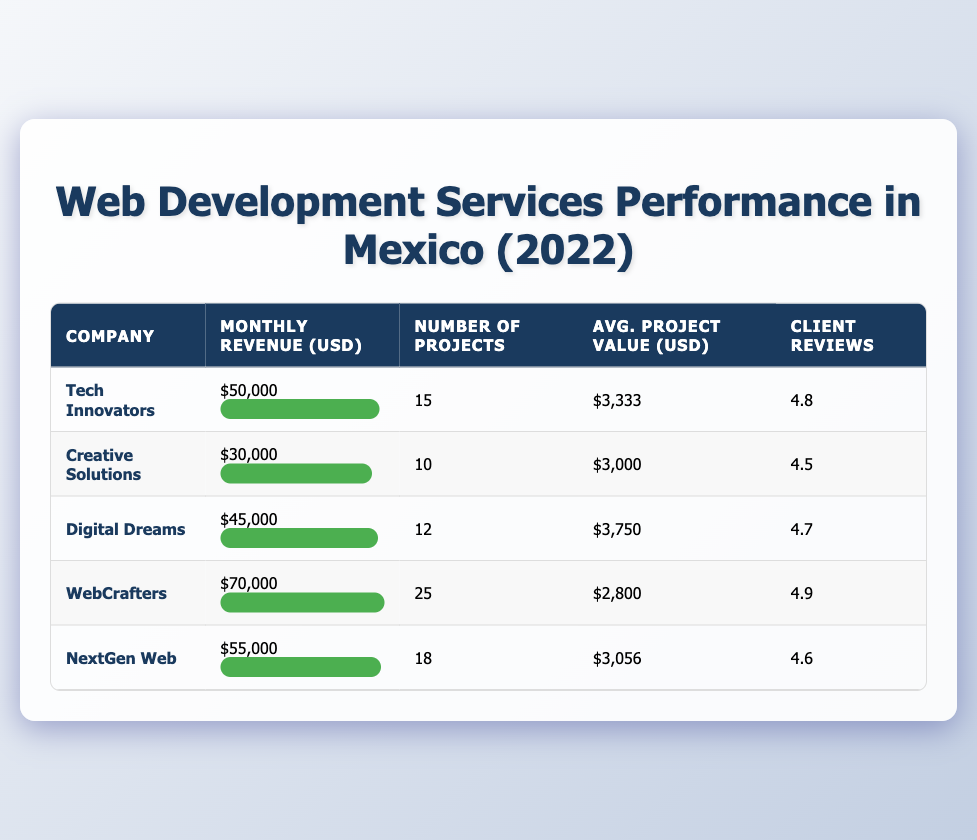What is the company with the highest monthly revenue? To find the company with the highest monthly revenue, I can compare the monthly revenue values from the table. The companies are WebCrafters ($70,000), NextGen Web ($55,000), Tech Innovators ($50,000), Digital Dreams ($45,000), and Creative Solutions ($30,000). WebCrafters has the highest revenue at $70,000.
Answer: WebCrafters What is the average project value for Creative Solutions? The average project value for Creative Solutions is displayed in the table as $3,000. There are no calculations needed as it is a specific value shown directly.
Answer: $3,000 How many projects did the company Digital Dreams complete? The number of projects completed by Digital Dreams is listed in the table as 12. This is a straightforward retrieval from the respective row of the table.
Answer: 12 What is the total monthly revenue of all listed companies? To find the total monthly revenue, I will sum the revenues of all companies: $50,000 (Tech Innovators) + $30,000 (Creative Solutions) + $45,000 (Digital Dreams) + $70,000 (WebCrafters) + $55,000 (NextGen Web) = $250,000.
Answer: $250,000 Is there any company with a client review rating of 5.0? By reviewing the client reviews in the table, I see the highest rating is 4.9 (WebCrafters), and no company has a rating of 5.0. Therefore, the answer is no.
Answer: No What is the difference in monthly revenue between WebCrafters and Creative Solutions? The monthly revenue for WebCrafters is $70,000 and for Creative Solutions it is $30,000. To find the difference, I will subtract: $70,000 - $30,000 = $40,000.
Answer: $40,000 How many more projects did WebCrafters complete compared to NextGen Web? WebCrafters completed 25 projects while NextGen Web completed 18 projects. I will calculate the difference: 25 - 18 = 7.
Answer: 7 What percentage of the average project value is associated with Digital Dreams compared to Tech Innovators? Digital Dreams has an average project value of $3,750 and Tech Innovators has $3,333. To find the percentage, I will calculate: ($3,750 / $3,333) * 100 ≈ 112.5%. This indicates Digital Dreams' value is about 112.5% of Tech Innovators'.
Answer: 112.5% 